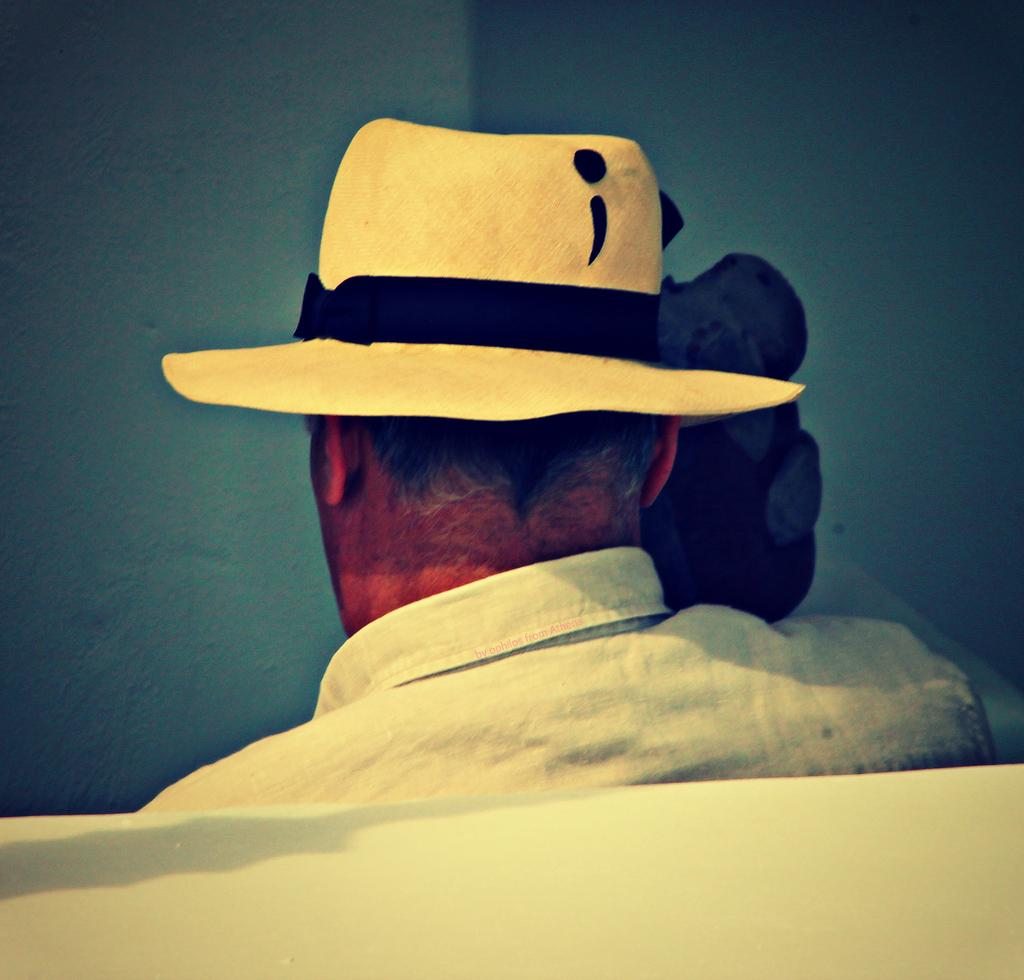Who or what is the main subject in the image? There is a person in the image. What is the person wearing on their upper body? The person is wearing a white shirt. What type of headwear is the person wearing? The person is wearing a hat. How many cars can be seen in the image? There are no cars visible in the image; it features a person wearing a white shirt and a hat. What type of chin does the person have in the image? There is no chin mentioned or visible in the image; it only shows a person wearing a white shirt and a hat. 